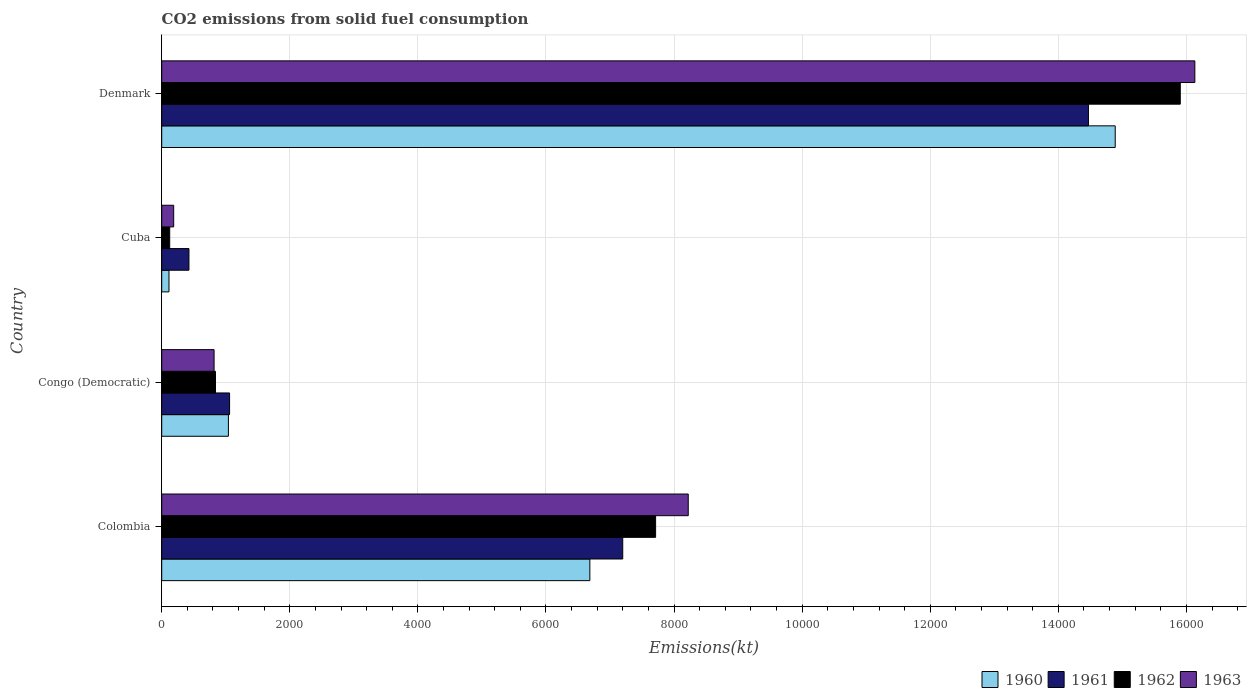How many bars are there on the 3rd tick from the bottom?
Offer a terse response. 4. What is the label of the 3rd group of bars from the top?
Ensure brevity in your answer.  Congo (Democratic). What is the amount of CO2 emitted in 1961 in Cuba?
Make the answer very short. 425.37. Across all countries, what is the maximum amount of CO2 emitted in 1962?
Provide a succinct answer. 1.59e+04. Across all countries, what is the minimum amount of CO2 emitted in 1963?
Give a very brief answer. 187.02. In which country was the amount of CO2 emitted in 1960 maximum?
Give a very brief answer. Denmark. In which country was the amount of CO2 emitted in 1962 minimum?
Ensure brevity in your answer.  Cuba. What is the total amount of CO2 emitted in 1962 in the graph?
Your response must be concise. 2.46e+04. What is the difference between the amount of CO2 emitted in 1962 in Congo (Democratic) and that in Denmark?
Provide a succinct answer. -1.51e+04. What is the difference between the amount of CO2 emitted in 1962 in Colombia and the amount of CO2 emitted in 1963 in Cuba?
Keep it short and to the point. 7524.68. What is the average amount of CO2 emitted in 1962 per country?
Your response must be concise. 6144.98. What is the difference between the amount of CO2 emitted in 1963 and amount of CO2 emitted in 1961 in Denmark?
Your answer should be very brief. 1661.15. In how many countries, is the amount of CO2 emitted in 1963 greater than 11200 kt?
Ensure brevity in your answer.  1. What is the ratio of the amount of CO2 emitted in 1961 in Congo (Democratic) to that in Cuba?
Your answer should be compact. 2.49. What is the difference between the highest and the second highest amount of CO2 emitted in 1961?
Ensure brevity in your answer.  7271.66. What is the difference between the highest and the lowest amount of CO2 emitted in 1962?
Provide a short and direct response. 1.58e+04. In how many countries, is the amount of CO2 emitted in 1962 greater than the average amount of CO2 emitted in 1962 taken over all countries?
Offer a terse response. 2. Is it the case that in every country, the sum of the amount of CO2 emitted in 1963 and amount of CO2 emitted in 1962 is greater than the sum of amount of CO2 emitted in 1961 and amount of CO2 emitted in 1960?
Make the answer very short. No. What does the 4th bar from the bottom in Colombia represents?
Ensure brevity in your answer.  1963. Are all the bars in the graph horizontal?
Keep it short and to the point. Yes. How many countries are there in the graph?
Offer a terse response. 4. Does the graph contain any zero values?
Offer a very short reply. No. Does the graph contain grids?
Ensure brevity in your answer.  Yes. Where does the legend appear in the graph?
Your answer should be compact. Bottom right. How are the legend labels stacked?
Provide a short and direct response. Horizontal. What is the title of the graph?
Offer a very short reply. CO2 emissions from solid fuel consumption. What is the label or title of the X-axis?
Your answer should be compact. Emissions(kt). What is the Emissions(kt) of 1960 in Colombia?
Your response must be concise. 6684.94. What is the Emissions(kt) of 1961 in Colombia?
Provide a short and direct response. 7198.32. What is the Emissions(kt) of 1962 in Colombia?
Ensure brevity in your answer.  7711.7. What is the Emissions(kt) in 1963 in Colombia?
Make the answer very short. 8221.41. What is the Emissions(kt) of 1960 in Congo (Democratic)?
Provide a succinct answer. 1041.43. What is the Emissions(kt) of 1961 in Congo (Democratic)?
Give a very brief answer. 1059.76. What is the Emissions(kt) of 1962 in Congo (Democratic)?
Your answer should be compact. 839.74. What is the Emissions(kt) in 1963 in Congo (Democratic)?
Offer a very short reply. 817.74. What is the Emissions(kt) in 1960 in Cuba?
Provide a succinct answer. 113.68. What is the Emissions(kt) in 1961 in Cuba?
Your answer should be compact. 425.37. What is the Emissions(kt) of 1962 in Cuba?
Your response must be concise. 124.68. What is the Emissions(kt) of 1963 in Cuba?
Give a very brief answer. 187.02. What is the Emissions(kt) in 1960 in Denmark?
Ensure brevity in your answer.  1.49e+04. What is the Emissions(kt) of 1961 in Denmark?
Provide a short and direct response. 1.45e+04. What is the Emissions(kt) in 1962 in Denmark?
Provide a succinct answer. 1.59e+04. What is the Emissions(kt) in 1963 in Denmark?
Offer a terse response. 1.61e+04. Across all countries, what is the maximum Emissions(kt) in 1960?
Ensure brevity in your answer.  1.49e+04. Across all countries, what is the maximum Emissions(kt) in 1961?
Your answer should be very brief. 1.45e+04. Across all countries, what is the maximum Emissions(kt) in 1962?
Offer a very short reply. 1.59e+04. Across all countries, what is the maximum Emissions(kt) of 1963?
Offer a very short reply. 1.61e+04. Across all countries, what is the minimum Emissions(kt) of 1960?
Give a very brief answer. 113.68. Across all countries, what is the minimum Emissions(kt) of 1961?
Ensure brevity in your answer.  425.37. Across all countries, what is the minimum Emissions(kt) in 1962?
Your answer should be compact. 124.68. Across all countries, what is the minimum Emissions(kt) in 1963?
Keep it short and to the point. 187.02. What is the total Emissions(kt) in 1960 in the graph?
Your response must be concise. 2.27e+04. What is the total Emissions(kt) in 1961 in the graph?
Keep it short and to the point. 2.32e+04. What is the total Emissions(kt) of 1962 in the graph?
Ensure brevity in your answer.  2.46e+04. What is the total Emissions(kt) of 1963 in the graph?
Provide a short and direct response. 2.54e+04. What is the difference between the Emissions(kt) in 1960 in Colombia and that in Congo (Democratic)?
Your answer should be compact. 5643.51. What is the difference between the Emissions(kt) in 1961 in Colombia and that in Congo (Democratic)?
Keep it short and to the point. 6138.56. What is the difference between the Emissions(kt) of 1962 in Colombia and that in Congo (Democratic)?
Your response must be concise. 6871.96. What is the difference between the Emissions(kt) of 1963 in Colombia and that in Congo (Democratic)?
Your answer should be compact. 7403.67. What is the difference between the Emissions(kt) of 1960 in Colombia and that in Cuba?
Keep it short and to the point. 6571.26. What is the difference between the Emissions(kt) of 1961 in Colombia and that in Cuba?
Give a very brief answer. 6772.95. What is the difference between the Emissions(kt) of 1962 in Colombia and that in Cuba?
Your answer should be very brief. 7587.02. What is the difference between the Emissions(kt) in 1963 in Colombia and that in Cuba?
Offer a very short reply. 8034.4. What is the difference between the Emissions(kt) of 1960 in Colombia and that in Denmark?
Ensure brevity in your answer.  -8203.08. What is the difference between the Emissions(kt) in 1961 in Colombia and that in Denmark?
Provide a succinct answer. -7271.66. What is the difference between the Emissions(kt) in 1962 in Colombia and that in Denmark?
Ensure brevity in your answer.  -8192.08. What is the difference between the Emissions(kt) in 1963 in Colombia and that in Denmark?
Your answer should be very brief. -7909.72. What is the difference between the Emissions(kt) in 1960 in Congo (Democratic) and that in Cuba?
Offer a terse response. 927.75. What is the difference between the Emissions(kt) of 1961 in Congo (Democratic) and that in Cuba?
Your answer should be very brief. 634.39. What is the difference between the Emissions(kt) of 1962 in Congo (Democratic) and that in Cuba?
Your answer should be very brief. 715.07. What is the difference between the Emissions(kt) in 1963 in Congo (Democratic) and that in Cuba?
Your answer should be compact. 630.72. What is the difference between the Emissions(kt) of 1960 in Congo (Democratic) and that in Denmark?
Give a very brief answer. -1.38e+04. What is the difference between the Emissions(kt) in 1961 in Congo (Democratic) and that in Denmark?
Your answer should be compact. -1.34e+04. What is the difference between the Emissions(kt) of 1962 in Congo (Democratic) and that in Denmark?
Your answer should be very brief. -1.51e+04. What is the difference between the Emissions(kt) of 1963 in Congo (Democratic) and that in Denmark?
Offer a terse response. -1.53e+04. What is the difference between the Emissions(kt) in 1960 in Cuba and that in Denmark?
Provide a short and direct response. -1.48e+04. What is the difference between the Emissions(kt) in 1961 in Cuba and that in Denmark?
Your answer should be very brief. -1.40e+04. What is the difference between the Emissions(kt) of 1962 in Cuba and that in Denmark?
Your answer should be compact. -1.58e+04. What is the difference between the Emissions(kt) in 1963 in Cuba and that in Denmark?
Keep it short and to the point. -1.59e+04. What is the difference between the Emissions(kt) in 1960 in Colombia and the Emissions(kt) in 1961 in Congo (Democratic)?
Offer a very short reply. 5625.18. What is the difference between the Emissions(kt) of 1960 in Colombia and the Emissions(kt) of 1962 in Congo (Democratic)?
Offer a terse response. 5845.2. What is the difference between the Emissions(kt) in 1960 in Colombia and the Emissions(kt) in 1963 in Congo (Democratic)?
Give a very brief answer. 5867.2. What is the difference between the Emissions(kt) in 1961 in Colombia and the Emissions(kt) in 1962 in Congo (Democratic)?
Give a very brief answer. 6358.58. What is the difference between the Emissions(kt) of 1961 in Colombia and the Emissions(kt) of 1963 in Congo (Democratic)?
Give a very brief answer. 6380.58. What is the difference between the Emissions(kt) in 1962 in Colombia and the Emissions(kt) in 1963 in Congo (Democratic)?
Your response must be concise. 6893.96. What is the difference between the Emissions(kt) of 1960 in Colombia and the Emissions(kt) of 1961 in Cuba?
Provide a succinct answer. 6259.57. What is the difference between the Emissions(kt) of 1960 in Colombia and the Emissions(kt) of 1962 in Cuba?
Provide a short and direct response. 6560.26. What is the difference between the Emissions(kt) in 1960 in Colombia and the Emissions(kt) in 1963 in Cuba?
Make the answer very short. 6497.92. What is the difference between the Emissions(kt) of 1961 in Colombia and the Emissions(kt) of 1962 in Cuba?
Your answer should be very brief. 7073.64. What is the difference between the Emissions(kt) in 1961 in Colombia and the Emissions(kt) in 1963 in Cuba?
Give a very brief answer. 7011.3. What is the difference between the Emissions(kt) of 1962 in Colombia and the Emissions(kt) of 1963 in Cuba?
Your response must be concise. 7524.68. What is the difference between the Emissions(kt) of 1960 in Colombia and the Emissions(kt) of 1961 in Denmark?
Make the answer very short. -7785.04. What is the difference between the Emissions(kt) of 1960 in Colombia and the Emissions(kt) of 1962 in Denmark?
Ensure brevity in your answer.  -9218.84. What is the difference between the Emissions(kt) in 1960 in Colombia and the Emissions(kt) in 1963 in Denmark?
Offer a terse response. -9446.19. What is the difference between the Emissions(kt) in 1961 in Colombia and the Emissions(kt) in 1962 in Denmark?
Provide a succinct answer. -8705.46. What is the difference between the Emissions(kt) in 1961 in Colombia and the Emissions(kt) in 1963 in Denmark?
Make the answer very short. -8932.81. What is the difference between the Emissions(kt) of 1962 in Colombia and the Emissions(kt) of 1963 in Denmark?
Offer a very short reply. -8419.43. What is the difference between the Emissions(kt) of 1960 in Congo (Democratic) and the Emissions(kt) of 1961 in Cuba?
Provide a succinct answer. 616.06. What is the difference between the Emissions(kt) of 1960 in Congo (Democratic) and the Emissions(kt) of 1962 in Cuba?
Keep it short and to the point. 916.75. What is the difference between the Emissions(kt) of 1960 in Congo (Democratic) and the Emissions(kt) of 1963 in Cuba?
Offer a terse response. 854.41. What is the difference between the Emissions(kt) in 1961 in Congo (Democratic) and the Emissions(kt) in 1962 in Cuba?
Your answer should be very brief. 935.09. What is the difference between the Emissions(kt) of 1961 in Congo (Democratic) and the Emissions(kt) of 1963 in Cuba?
Provide a succinct answer. 872.75. What is the difference between the Emissions(kt) in 1962 in Congo (Democratic) and the Emissions(kt) in 1963 in Cuba?
Your answer should be compact. 652.73. What is the difference between the Emissions(kt) of 1960 in Congo (Democratic) and the Emissions(kt) of 1961 in Denmark?
Keep it short and to the point. -1.34e+04. What is the difference between the Emissions(kt) in 1960 in Congo (Democratic) and the Emissions(kt) in 1962 in Denmark?
Your answer should be very brief. -1.49e+04. What is the difference between the Emissions(kt) of 1960 in Congo (Democratic) and the Emissions(kt) of 1963 in Denmark?
Offer a terse response. -1.51e+04. What is the difference between the Emissions(kt) in 1961 in Congo (Democratic) and the Emissions(kt) in 1962 in Denmark?
Provide a succinct answer. -1.48e+04. What is the difference between the Emissions(kt) in 1961 in Congo (Democratic) and the Emissions(kt) in 1963 in Denmark?
Your answer should be compact. -1.51e+04. What is the difference between the Emissions(kt) in 1962 in Congo (Democratic) and the Emissions(kt) in 1963 in Denmark?
Give a very brief answer. -1.53e+04. What is the difference between the Emissions(kt) of 1960 in Cuba and the Emissions(kt) of 1961 in Denmark?
Make the answer very short. -1.44e+04. What is the difference between the Emissions(kt) of 1960 in Cuba and the Emissions(kt) of 1962 in Denmark?
Offer a terse response. -1.58e+04. What is the difference between the Emissions(kt) in 1960 in Cuba and the Emissions(kt) in 1963 in Denmark?
Offer a terse response. -1.60e+04. What is the difference between the Emissions(kt) of 1961 in Cuba and the Emissions(kt) of 1962 in Denmark?
Offer a terse response. -1.55e+04. What is the difference between the Emissions(kt) of 1961 in Cuba and the Emissions(kt) of 1963 in Denmark?
Your answer should be compact. -1.57e+04. What is the difference between the Emissions(kt) in 1962 in Cuba and the Emissions(kt) in 1963 in Denmark?
Provide a succinct answer. -1.60e+04. What is the average Emissions(kt) of 1960 per country?
Ensure brevity in your answer.  5682.02. What is the average Emissions(kt) in 1961 per country?
Provide a succinct answer. 5788.36. What is the average Emissions(kt) in 1962 per country?
Your response must be concise. 6144.98. What is the average Emissions(kt) in 1963 per country?
Keep it short and to the point. 6339.33. What is the difference between the Emissions(kt) in 1960 and Emissions(kt) in 1961 in Colombia?
Provide a short and direct response. -513.38. What is the difference between the Emissions(kt) in 1960 and Emissions(kt) in 1962 in Colombia?
Ensure brevity in your answer.  -1026.76. What is the difference between the Emissions(kt) of 1960 and Emissions(kt) of 1963 in Colombia?
Offer a very short reply. -1536.47. What is the difference between the Emissions(kt) in 1961 and Emissions(kt) in 1962 in Colombia?
Keep it short and to the point. -513.38. What is the difference between the Emissions(kt) in 1961 and Emissions(kt) in 1963 in Colombia?
Your answer should be very brief. -1023.09. What is the difference between the Emissions(kt) of 1962 and Emissions(kt) of 1963 in Colombia?
Offer a terse response. -509.71. What is the difference between the Emissions(kt) of 1960 and Emissions(kt) of 1961 in Congo (Democratic)?
Offer a terse response. -18.34. What is the difference between the Emissions(kt) of 1960 and Emissions(kt) of 1962 in Congo (Democratic)?
Your answer should be compact. 201.69. What is the difference between the Emissions(kt) of 1960 and Emissions(kt) of 1963 in Congo (Democratic)?
Provide a succinct answer. 223.69. What is the difference between the Emissions(kt) of 1961 and Emissions(kt) of 1962 in Congo (Democratic)?
Give a very brief answer. 220.02. What is the difference between the Emissions(kt) of 1961 and Emissions(kt) of 1963 in Congo (Democratic)?
Offer a terse response. 242.02. What is the difference between the Emissions(kt) of 1962 and Emissions(kt) of 1963 in Congo (Democratic)?
Your answer should be compact. 22. What is the difference between the Emissions(kt) in 1960 and Emissions(kt) in 1961 in Cuba?
Make the answer very short. -311.69. What is the difference between the Emissions(kt) in 1960 and Emissions(kt) in 1962 in Cuba?
Your answer should be very brief. -11. What is the difference between the Emissions(kt) in 1960 and Emissions(kt) in 1963 in Cuba?
Offer a very short reply. -73.34. What is the difference between the Emissions(kt) in 1961 and Emissions(kt) in 1962 in Cuba?
Offer a very short reply. 300.69. What is the difference between the Emissions(kt) in 1961 and Emissions(kt) in 1963 in Cuba?
Your answer should be very brief. 238.35. What is the difference between the Emissions(kt) in 1962 and Emissions(kt) in 1963 in Cuba?
Your answer should be very brief. -62.34. What is the difference between the Emissions(kt) in 1960 and Emissions(kt) in 1961 in Denmark?
Your answer should be compact. 418.04. What is the difference between the Emissions(kt) of 1960 and Emissions(kt) of 1962 in Denmark?
Keep it short and to the point. -1015.76. What is the difference between the Emissions(kt) of 1960 and Emissions(kt) of 1963 in Denmark?
Make the answer very short. -1243.11. What is the difference between the Emissions(kt) in 1961 and Emissions(kt) in 1962 in Denmark?
Provide a succinct answer. -1433.8. What is the difference between the Emissions(kt) of 1961 and Emissions(kt) of 1963 in Denmark?
Provide a succinct answer. -1661.15. What is the difference between the Emissions(kt) in 1962 and Emissions(kt) in 1963 in Denmark?
Give a very brief answer. -227.35. What is the ratio of the Emissions(kt) in 1960 in Colombia to that in Congo (Democratic)?
Provide a short and direct response. 6.42. What is the ratio of the Emissions(kt) of 1961 in Colombia to that in Congo (Democratic)?
Provide a short and direct response. 6.79. What is the ratio of the Emissions(kt) of 1962 in Colombia to that in Congo (Democratic)?
Provide a short and direct response. 9.18. What is the ratio of the Emissions(kt) in 1963 in Colombia to that in Congo (Democratic)?
Provide a succinct answer. 10.05. What is the ratio of the Emissions(kt) of 1960 in Colombia to that in Cuba?
Give a very brief answer. 58.81. What is the ratio of the Emissions(kt) of 1961 in Colombia to that in Cuba?
Give a very brief answer. 16.92. What is the ratio of the Emissions(kt) in 1962 in Colombia to that in Cuba?
Provide a short and direct response. 61.85. What is the ratio of the Emissions(kt) of 1963 in Colombia to that in Cuba?
Your answer should be compact. 43.96. What is the ratio of the Emissions(kt) of 1960 in Colombia to that in Denmark?
Give a very brief answer. 0.45. What is the ratio of the Emissions(kt) of 1961 in Colombia to that in Denmark?
Your response must be concise. 0.5. What is the ratio of the Emissions(kt) of 1962 in Colombia to that in Denmark?
Provide a succinct answer. 0.48. What is the ratio of the Emissions(kt) of 1963 in Colombia to that in Denmark?
Keep it short and to the point. 0.51. What is the ratio of the Emissions(kt) of 1960 in Congo (Democratic) to that in Cuba?
Ensure brevity in your answer.  9.16. What is the ratio of the Emissions(kt) of 1961 in Congo (Democratic) to that in Cuba?
Keep it short and to the point. 2.49. What is the ratio of the Emissions(kt) of 1962 in Congo (Democratic) to that in Cuba?
Your response must be concise. 6.74. What is the ratio of the Emissions(kt) of 1963 in Congo (Democratic) to that in Cuba?
Keep it short and to the point. 4.37. What is the ratio of the Emissions(kt) in 1960 in Congo (Democratic) to that in Denmark?
Your answer should be very brief. 0.07. What is the ratio of the Emissions(kt) in 1961 in Congo (Democratic) to that in Denmark?
Provide a succinct answer. 0.07. What is the ratio of the Emissions(kt) of 1962 in Congo (Democratic) to that in Denmark?
Ensure brevity in your answer.  0.05. What is the ratio of the Emissions(kt) of 1963 in Congo (Democratic) to that in Denmark?
Your answer should be very brief. 0.05. What is the ratio of the Emissions(kt) in 1960 in Cuba to that in Denmark?
Offer a terse response. 0.01. What is the ratio of the Emissions(kt) in 1961 in Cuba to that in Denmark?
Provide a short and direct response. 0.03. What is the ratio of the Emissions(kt) of 1962 in Cuba to that in Denmark?
Offer a very short reply. 0.01. What is the ratio of the Emissions(kt) in 1963 in Cuba to that in Denmark?
Provide a succinct answer. 0.01. What is the difference between the highest and the second highest Emissions(kt) of 1960?
Provide a succinct answer. 8203.08. What is the difference between the highest and the second highest Emissions(kt) in 1961?
Provide a succinct answer. 7271.66. What is the difference between the highest and the second highest Emissions(kt) in 1962?
Your answer should be very brief. 8192.08. What is the difference between the highest and the second highest Emissions(kt) in 1963?
Your answer should be compact. 7909.72. What is the difference between the highest and the lowest Emissions(kt) in 1960?
Offer a terse response. 1.48e+04. What is the difference between the highest and the lowest Emissions(kt) in 1961?
Offer a terse response. 1.40e+04. What is the difference between the highest and the lowest Emissions(kt) of 1962?
Your answer should be compact. 1.58e+04. What is the difference between the highest and the lowest Emissions(kt) in 1963?
Your answer should be very brief. 1.59e+04. 